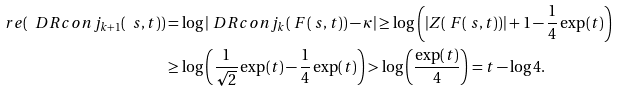Convert formula to latex. <formula><loc_0><loc_0><loc_500><loc_500>\ r e ( \ D R c o n j _ { k + 1 } ( \ s , t ) ) & = \log | \ D R c o n j _ { k } ( \ F ( \ s , t ) ) - \kappa | \geq \log \left ( | Z ( \ F ( \ s , t ) ) | + 1 - \frac { 1 } { 4 } \exp ( t ) \right ) \\ & \geq \log \left ( \frac { 1 } { \sqrt { 2 } } \exp ( t ) - \frac { 1 } { 4 } \exp ( t ) \right ) > \log \left ( \frac { \exp ( t ) } { 4 } \right ) = t - \log 4 .</formula> 